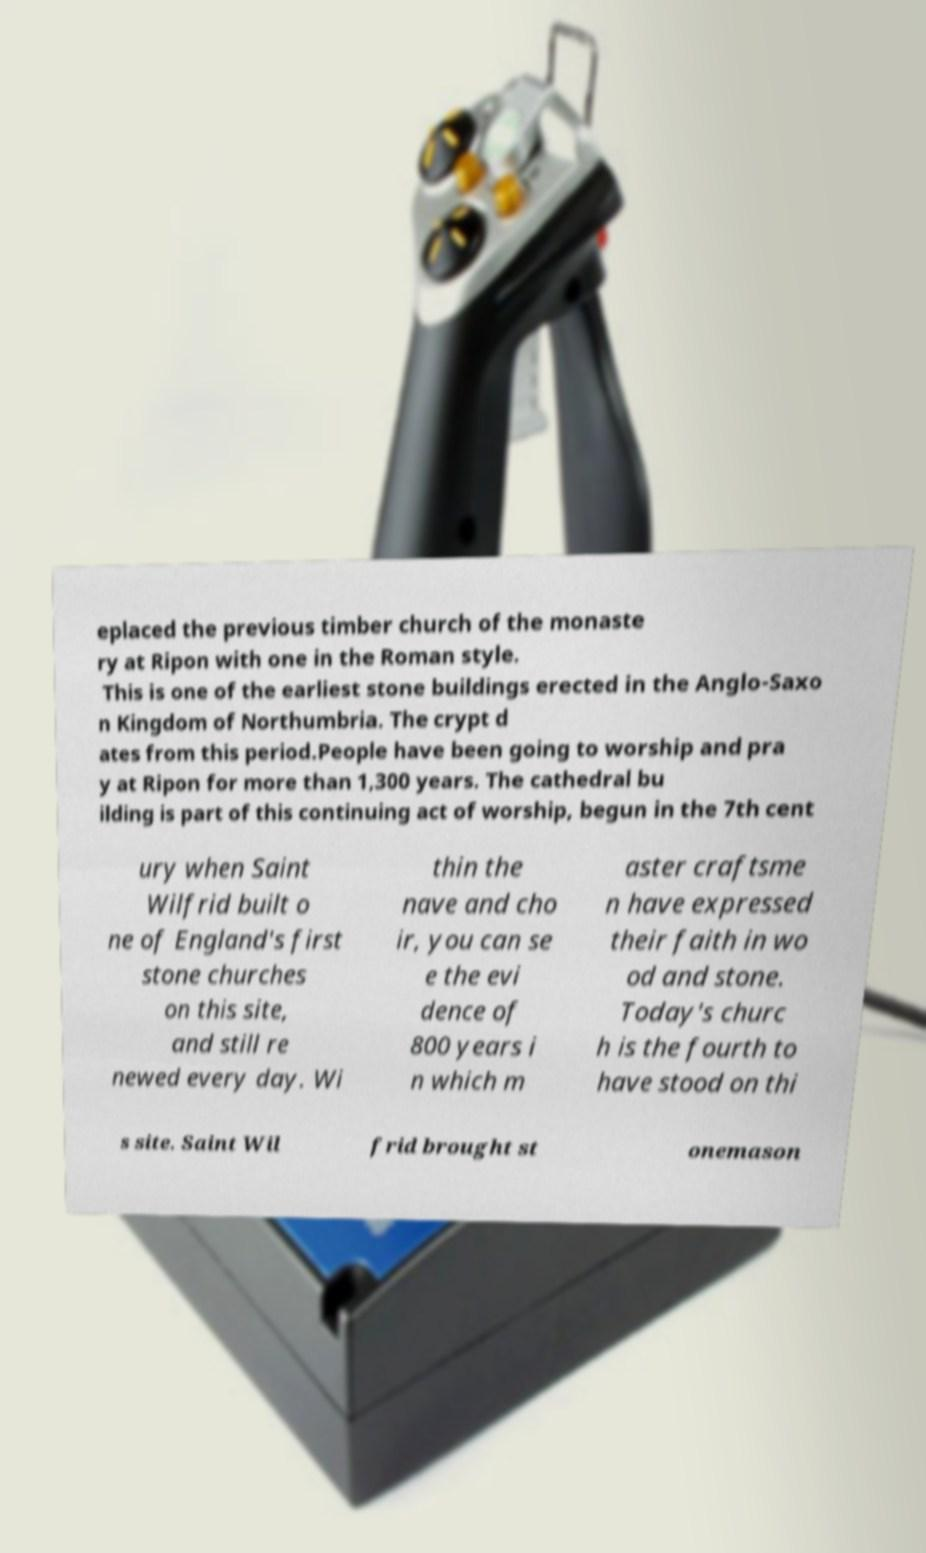Could you extract and type out the text from this image? eplaced the previous timber church of the monaste ry at Ripon with one in the Roman style. This is one of the earliest stone buildings erected in the Anglo-Saxo n Kingdom of Northumbria. The crypt d ates from this period.People have been going to worship and pra y at Ripon for more than 1,300 years. The cathedral bu ilding is part of this continuing act of worship, begun in the 7th cent ury when Saint Wilfrid built o ne of England's first stone churches on this site, and still re newed every day. Wi thin the nave and cho ir, you can se e the evi dence of 800 years i n which m aster craftsme n have expressed their faith in wo od and stone. Today's churc h is the fourth to have stood on thi s site. Saint Wil frid brought st onemason 